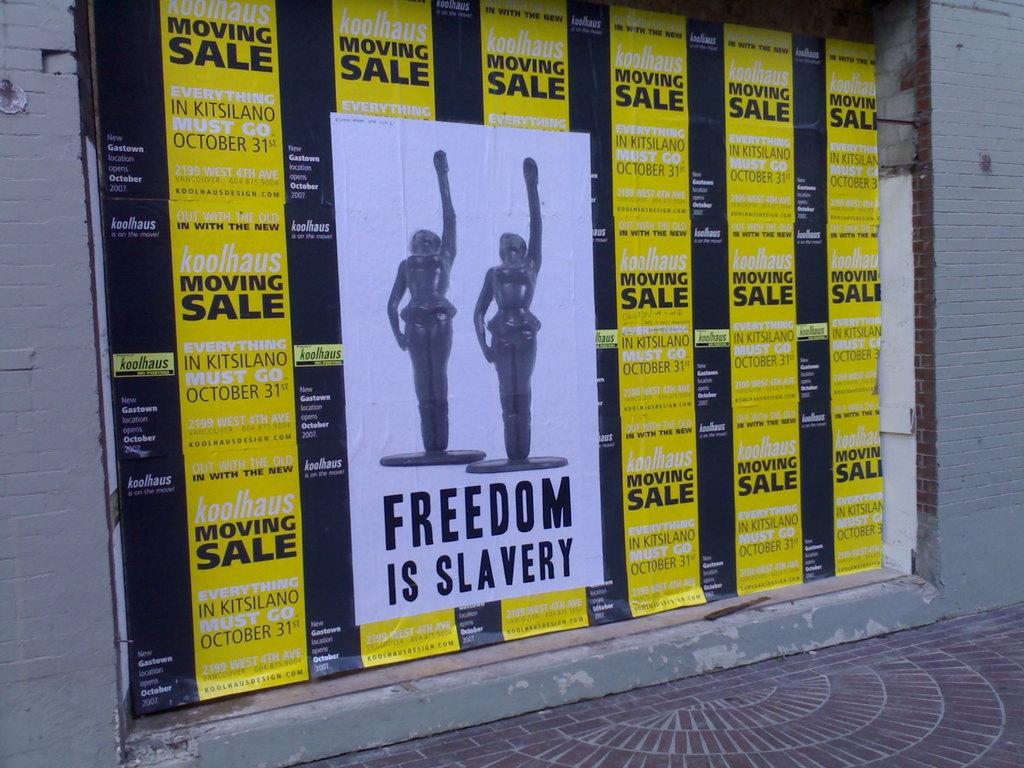<image>
Share a concise interpretation of the image provided. A poster with two statues in a power pose and the text "Freedom is Slavery" overlays yellow Koohaus moving sale posters. 